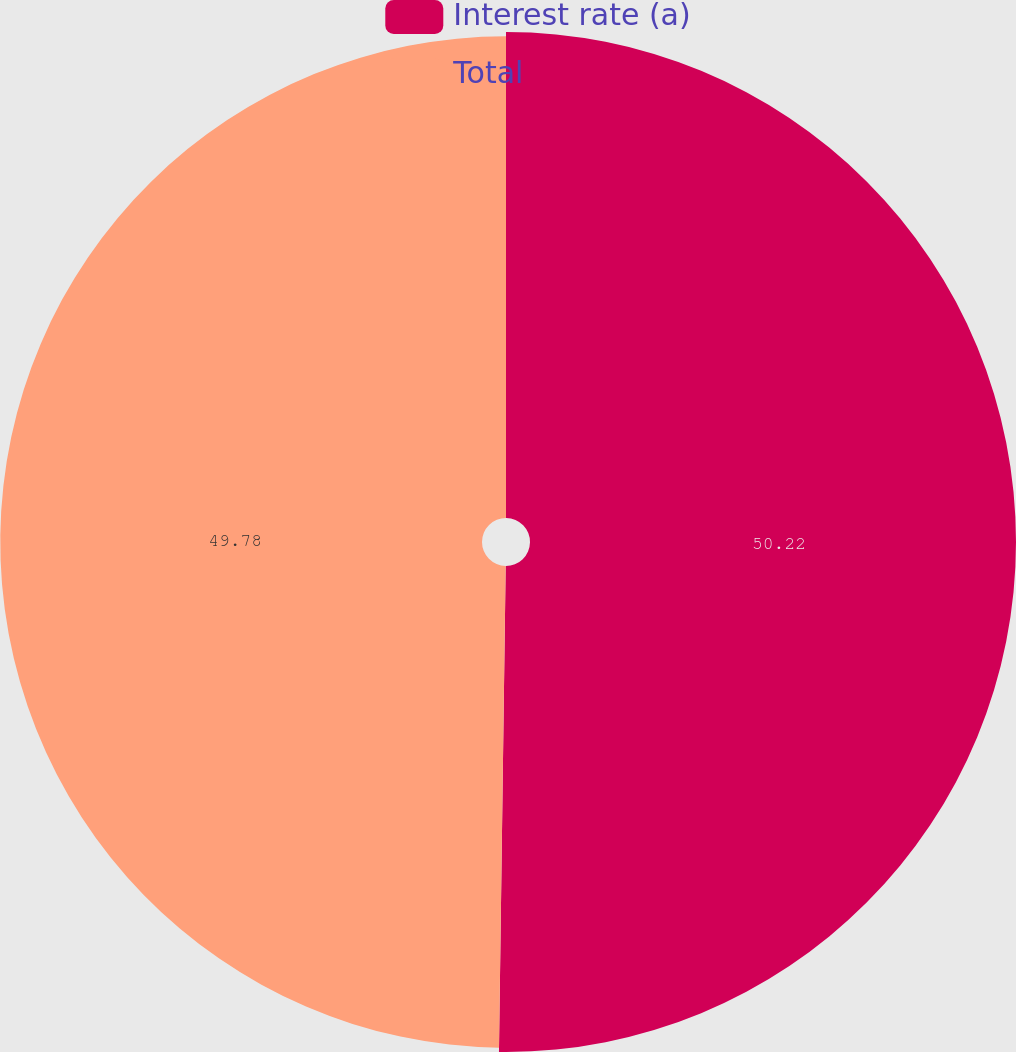Convert chart. <chart><loc_0><loc_0><loc_500><loc_500><pie_chart><fcel>Interest rate (a)<fcel>Total<nl><fcel>50.22%<fcel>49.78%<nl></chart> 